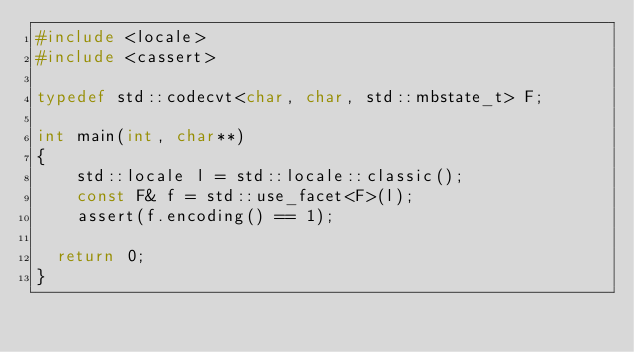Convert code to text. <code><loc_0><loc_0><loc_500><loc_500><_C++_>#include <locale>
#include <cassert>

typedef std::codecvt<char, char, std::mbstate_t> F;

int main(int, char**)
{
    std::locale l = std::locale::classic();
    const F& f = std::use_facet<F>(l);
    assert(f.encoding() == 1);

  return 0;
}
</code> 